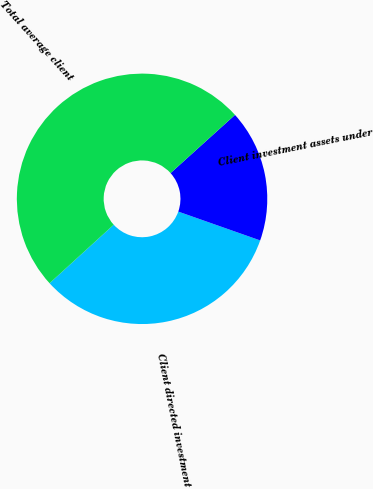Convert chart to OTSL. <chart><loc_0><loc_0><loc_500><loc_500><pie_chart><fcel>Client directed investment<fcel>Client investment assets under<fcel>Total average client<nl><fcel>32.84%<fcel>17.08%<fcel>50.08%<nl></chart> 